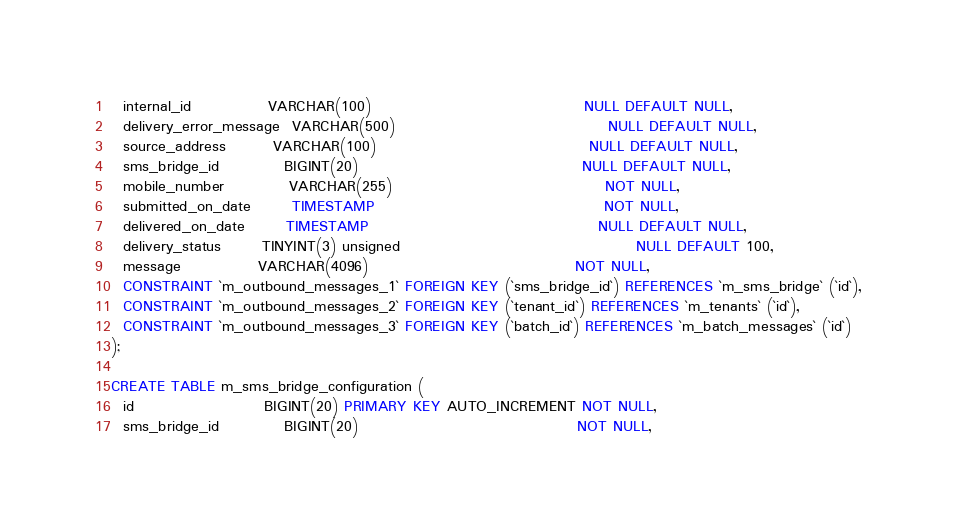<code> <loc_0><loc_0><loc_500><loc_500><_SQL_>  internal_id             VARCHAR(100)                                    NULL DEFAULT NULL,
  delivery_error_message  VARCHAR(500)                                    NULL DEFAULT NULL,
  source_address        VARCHAR(100)                                    NULL DEFAULT NULL,
  sms_bridge_id           BIGINT(20)                                      NULL DEFAULT NULL,
  mobile_number           VARCHAR(255)                                    NOT NULL,
  submitted_on_date       TIMESTAMP                                       NOT NULL,
  delivered_on_date       TIMESTAMP                                       NULL DEFAULT NULL,
  delivery_status       TINYINT(3) unsigned                                        NULL DEFAULT 100,
  message             VARCHAR(4096)                                   NOT NULL,
  CONSTRAINT `m_outbound_messages_1` FOREIGN KEY (`sms_bridge_id`) REFERENCES `m_sms_bridge` (`id`),
  CONSTRAINT `m_outbound_messages_2` FOREIGN KEY (`tenant_id`) REFERENCES `m_tenants` (`id`),
  CONSTRAINT `m_outbound_messages_3` FOREIGN KEY (`batch_id`) REFERENCES `m_batch_messages` (`id`)
);

CREATE TABLE m_sms_bridge_configuration (
  id                      BIGINT(20) PRIMARY KEY AUTO_INCREMENT NOT NULL,
  sms_bridge_id           BIGINT(20)                                     NOT NULL,</code> 